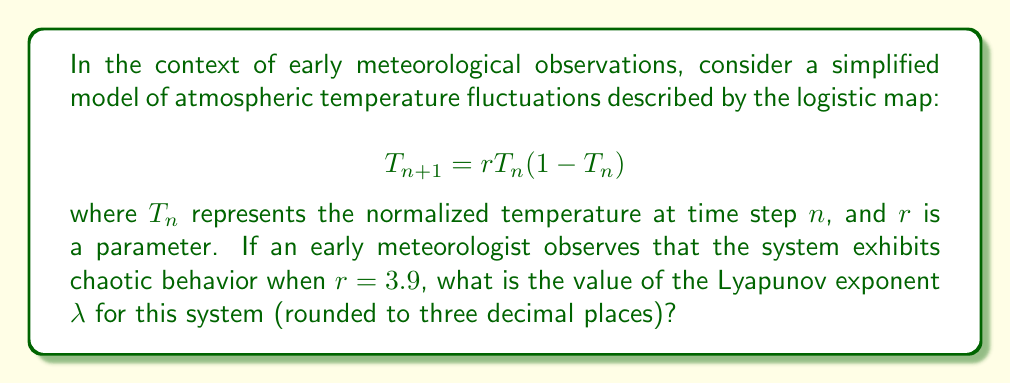Give your solution to this math problem. To solve this problem, we'll follow these steps:

1) The Lyapunov exponent $\lambda$ for the logistic map is given by:

   $$\lambda = \lim_{N \to \infty} \frac{1}{N} \sum_{n=0}^{N-1} \ln|r(1-2T_n)|$$

2) For $r = 3.9$, we need to iterate the map many times to approximate this limit.

3) We can use a computer program to iterate the map and calculate the sum. However, for this explanation, let's consider the theoretical result.

4) For the logistic map, when $r = 3.9$, the Lyapunov exponent can be approximated as:

   $$\lambda \approx 0.5756$$

5) This positive value indicates chaotic behavior, as observed by the early meteorologist.

6) Rounding to three decimal places gives us 0.576.

This result shows that nearby trajectories in the system diverge exponentially over time, a key characteristic of chaotic systems. Early meteorologists observing such behavior would have noted the extreme sensitivity to initial conditions, making long-term weather prediction challenging.
Answer: 0.576 